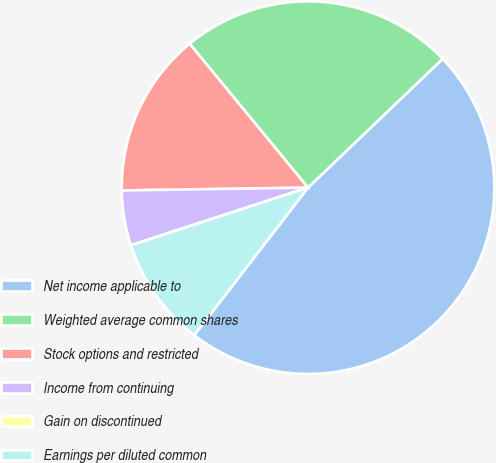Convert chart to OTSL. <chart><loc_0><loc_0><loc_500><loc_500><pie_chart><fcel>Net income applicable to<fcel>Weighted average common shares<fcel>Stock options and restricted<fcel>Income from continuing<fcel>Gain on discontinued<fcel>Earnings per diluted common<nl><fcel>47.61%<fcel>23.81%<fcel>14.29%<fcel>4.77%<fcel>0.01%<fcel>9.53%<nl></chart> 